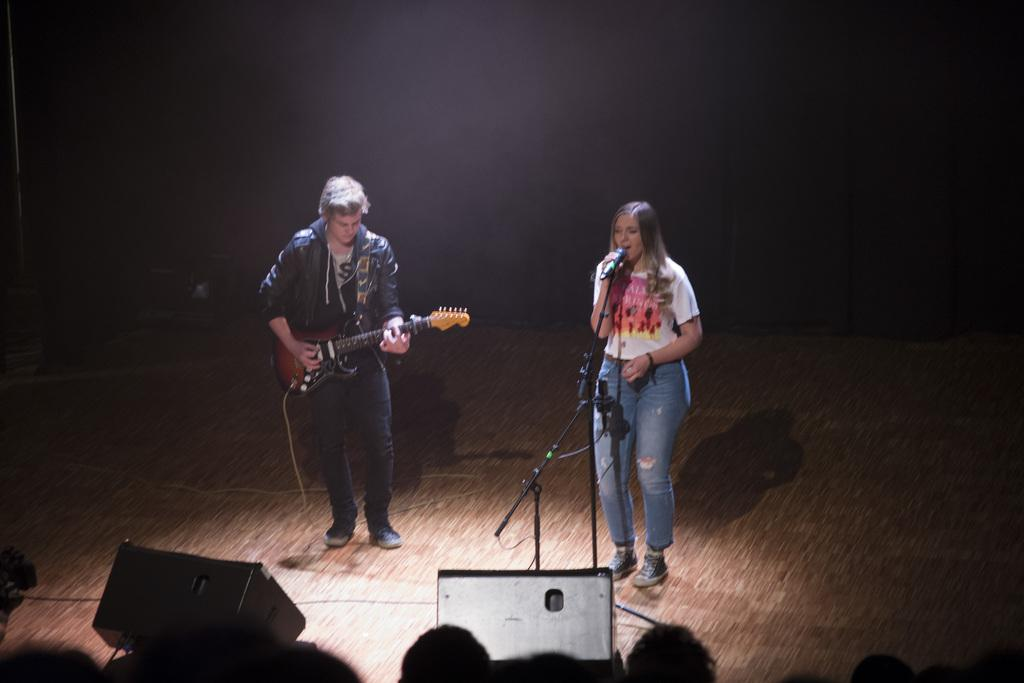What is the woman doing in the image? The woman is singing on a mic in the image. What is the man doing in the image? The man is playing guitar in the image. Where are the woman and the man located in the image? Both the woman and the man are on a stage. Who is present in front of the stage in the image? There is an audience in front of the stage, looking at the performers. What type of hair product is the woman using in the image? There is no indication of hair products being used in the image; the woman is singing on a mic. How does the audience's behavior change when it starts raining during the performance? There is no mention of rain in the image; the focus is on the woman singing and the man playing guitar on stage. 